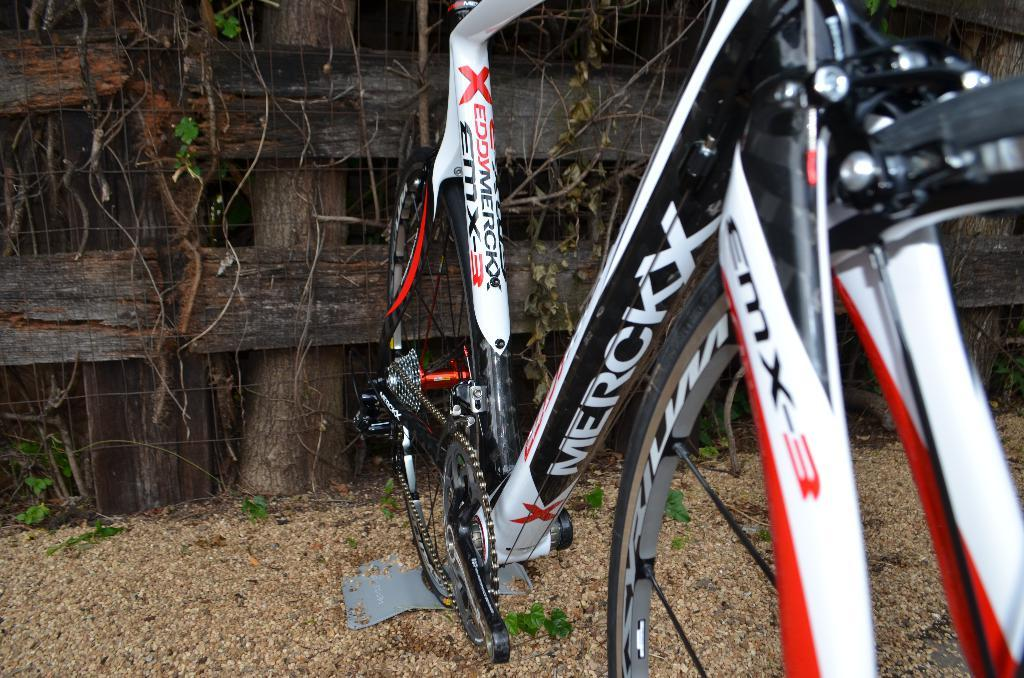What is the main object in the image? There is a bicycle in the image. What colors can be seen on the bicycle? The bicycle is white, red, and black in color. Where is the bicycle located in the image? The bicycle is on the ground. What type of vegetation is present in the image? There are green leaves from a tree in the image. What other objects can be seen in the image? There are wooden logs in the image. What type of story is being told by the sheet in the image? There is no sheet present in the image, so no story can be told by it. 